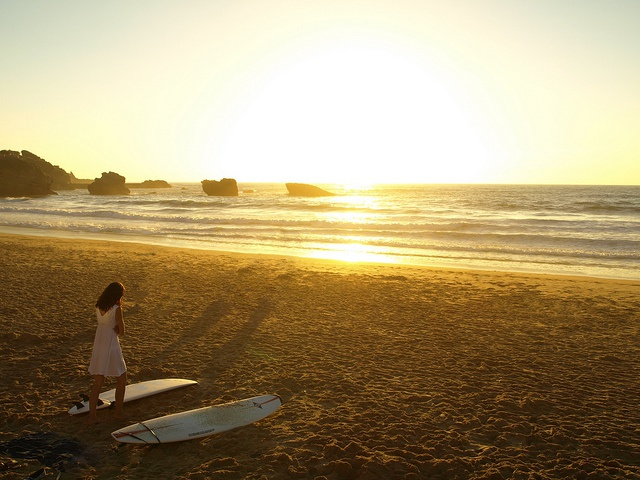Describe the objects in this image and their specific colors. I can see surfboard in lightgray, gray, black, and maroon tones, people in lightgray, maroon, black, and brown tones, and surfboard in lightgray, tan, black, and gray tones in this image. 